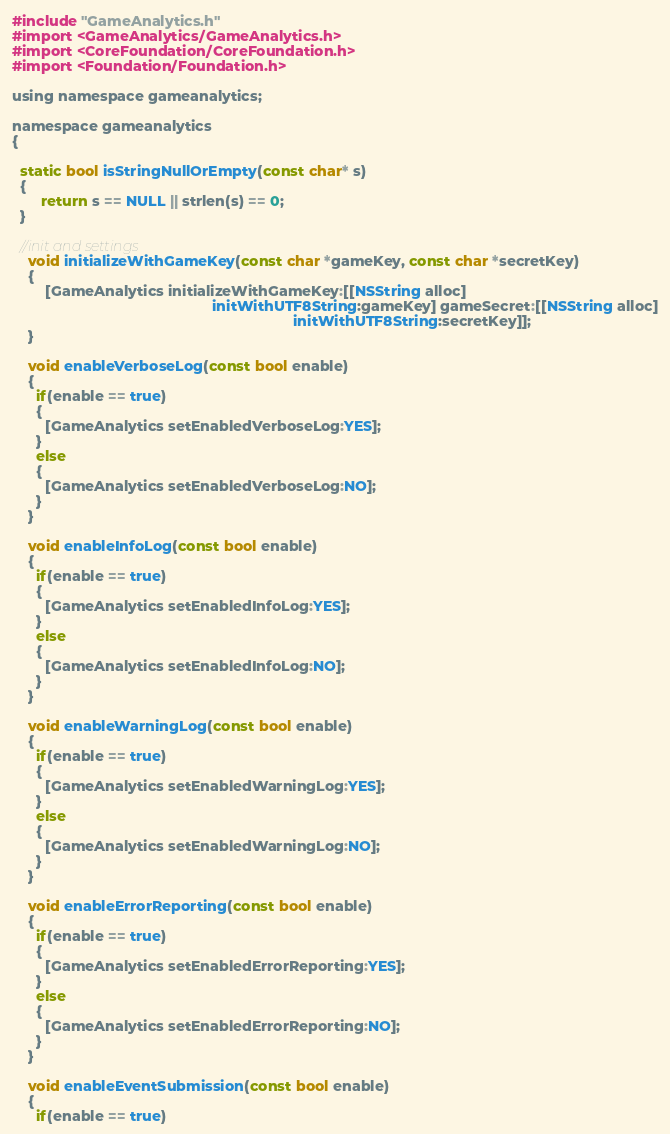<code> <loc_0><loc_0><loc_500><loc_500><_ObjectiveC_>#include "GameAnalytics.h"
#import <GameAnalytics/GameAnalytics.h>
#import <CoreFoundation/CoreFoundation.h>
#import <Foundation/Foundation.h>

using namespace gameanalytics;

namespace gameanalytics
{

  static bool isStringNullOrEmpty(const char* s)
  {
	   return s == NULL || strlen(s) == 0;
  }

  //init and settings
    void initializeWithGameKey(const char *gameKey, const char *secretKey)
    {
        [GameAnalytics initializeWithGameKey:[[NSString alloc]
        										 initWithUTF8String:gameKey] gameSecret:[[NSString alloc]
                             										 initWithUTF8String:secretKey]];
    }

    void enableVerboseLog(const bool enable)
    {
      if(enable == true)
      {
        [GameAnalytics setEnabledVerboseLog:YES];
      }
      else
      {
        [GameAnalytics setEnabledVerboseLog:NO];
      }
    }

    void enableInfoLog(const bool enable)
    {
      if(enable == true)
      {
        [GameAnalytics setEnabledInfoLog:YES];
      }
      else
      {
        [GameAnalytics setEnabledInfoLog:NO];
      }
    }

    void enableWarningLog(const bool enable)
    {
      if(enable == true)
      {
        [GameAnalytics setEnabledWarningLog:YES];
      }
      else
      {
        [GameAnalytics setEnabledWarningLog:NO];
      }
    }

    void enableErrorReporting(const bool enable)
    {
      if(enable == true)
      {
        [GameAnalytics setEnabledErrorReporting:YES];
      }
      else
      {
        [GameAnalytics setEnabledErrorReporting:NO];
      }
    }

    void enableEventSubmission(const bool enable)
    {
      if(enable == true)</code> 